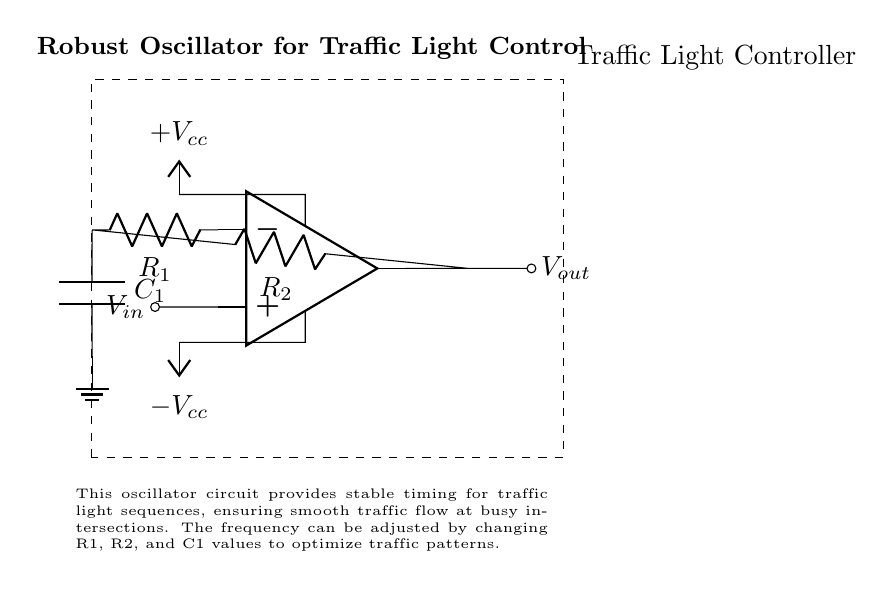What component is used for feedback in the circuit? The component used for feedback is a resistor, specifically R2, which connects the output of the operational amplifier back to its inverting input.
Answer: R2 What is the function of C1 in this oscillator circuit? C1 acts as a timing capacitor, helping to determine the frequency of oscillation by working with the resistors R1 and R2.
Answer: Timing capacitor What is the role of the operational amplifier in this circuit? The operational amplifier functions as a comparator, amplifying the input signal to generate a square wave output that oscillates between high and low states, controlling the timing of the traffic lights.
Answer: Comparator What happens to the frequency if R1 is increased? Increasing R1 will typically increase the time constant, which results in a decrease in the frequency of oscillation, as the circuit takes longer to charge and discharge the timing capacitor C1.
Answer: Decrease How many power supply connections are depicted in the circuit? There are two power supply connections, one for positive voltage and one for negative voltage, labeled +Vcc and -Vcc.
Answer: Two What is the purpose of the dashed rectangle in the diagram? The dashed rectangle represents the traffic light controller, indicating the section of the circuit that manages the operation and sequencing of traffic lights based on the oscillator's output.
Answer: Traffic light controller 